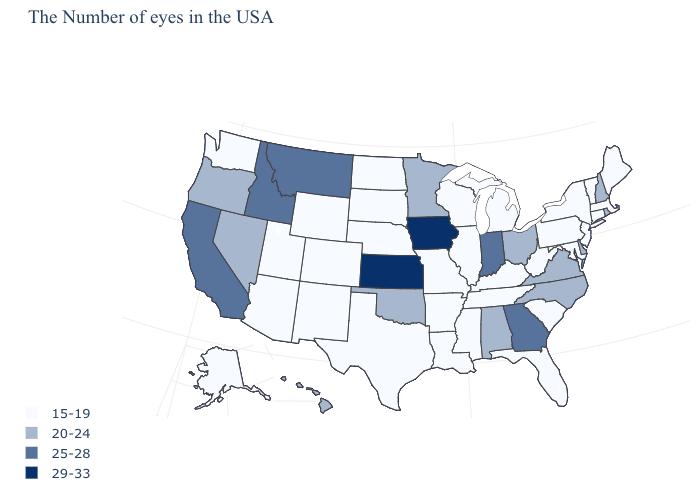Which states hav the highest value in the West?
Short answer required. Montana, Idaho, California. What is the value of Michigan?
Short answer required. 15-19. What is the value of Hawaii?
Quick response, please. 20-24. Name the states that have a value in the range 15-19?
Answer briefly. Maine, Massachusetts, Vermont, Connecticut, New York, New Jersey, Maryland, Pennsylvania, South Carolina, West Virginia, Florida, Michigan, Kentucky, Tennessee, Wisconsin, Illinois, Mississippi, Louisiana, Missouri, Arkansas, Nebraska, Texas, South Dakota, North Dakota, Wyoming, Colorado, New Mexico, Utah, Arizona, Washington, Alaska. Name the states that have a value in the range 15-19?
Concise answer only. Maine, Massachusetts, Vermont, Connecticut, New York, New Jersey, Maryland, Pennsylvania, South Carolina, West Virginia, Florida, Michigan, Kentucky, Tennessee, Wisconsin, Illinois, Mississippi, Louisiana, Missouri, Arkansas, Nebraska, Texas, South Dakota, North Dakota, Wyoming, Colorado, New Mexico, Utah, Arizona, Washington, Alaska. Which states have the highest value in the USA?
Give a very brief answer. Iowa, Kansas. Which states have the highest value in the USA?
Write a very short answer. Iowa, Kansas. What is the value of Minnesota?
Write a very short answer. 20-24. Which states hav the highest value in the South?
Keep it brief. Georgia. Among the states that border Vermont , does New Hampshire have the lowest value?
Write a very short answer. No. What is the lowest value in states that border North Dakota?
Keep it brief. 15-19. Which states have the lowest value in the USA?
Concise answer only. Maine, Massachusetts, Vermont, Connecticut, New York, New Jersey, Maryland, Pennsylvania, South Carolina, West Virginia, Florida, Michigan, Kentucky, Tennessee, Wisconsin, Illinois, Mississippi, Louisiana, Missouri, Arkansas, Nebraska, Texas, South Dakota, North Dakota, Wyoming, Colorado, New Mexico, Utah, Arizona, Washington, Alaska. Among the states that border Montana , does Idaho have the highest value?
Give a very brief answer. Yes. Which states have the highest value in the USA?
Give a very brief answer. Iowa, Kansas. Among the states that border Washington , does Idaho have the lowest value?
Keep it brief. No. 